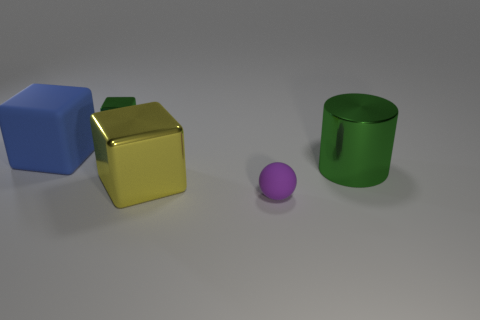Are there any tiny green blocks made of the same material as the yellow object? yes 